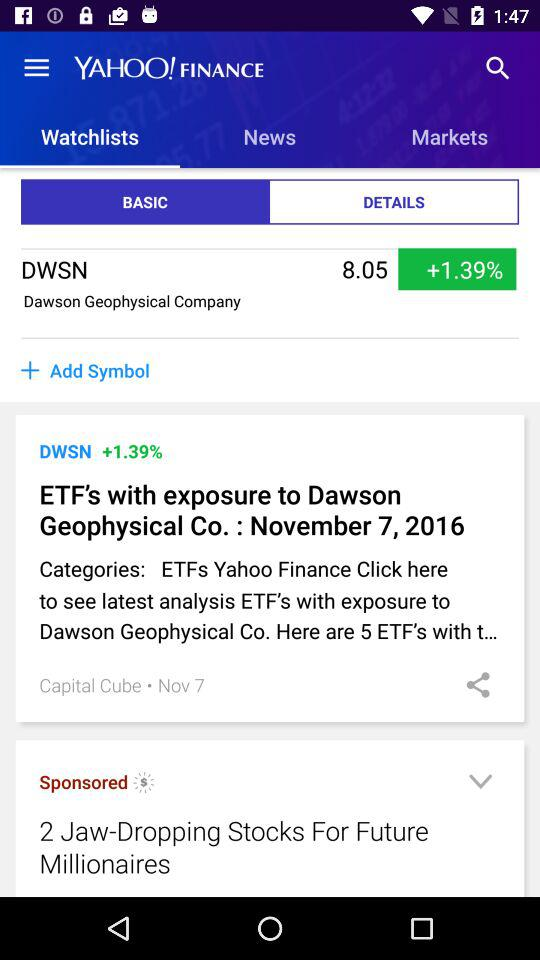On what date was the article "ETF's with exposure to Dawson Geophysical Co." posted? The date is November 7, 2016. 